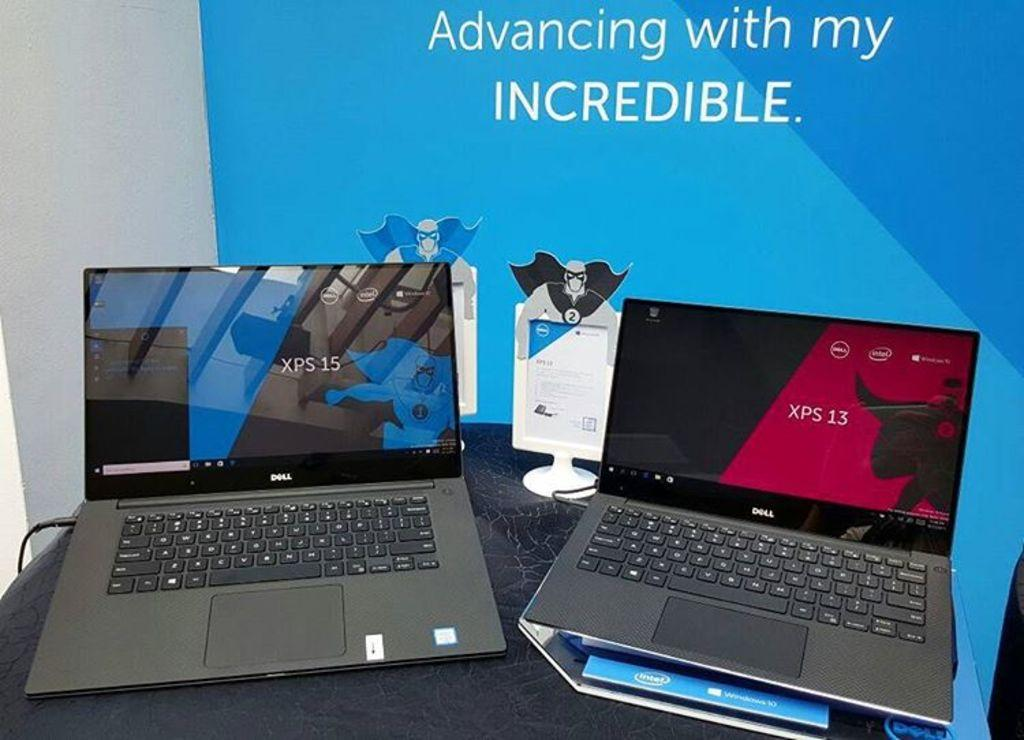<image>
Present a compact description of the photo's key features. Some Dell computers on display by a sign saying Incredible 